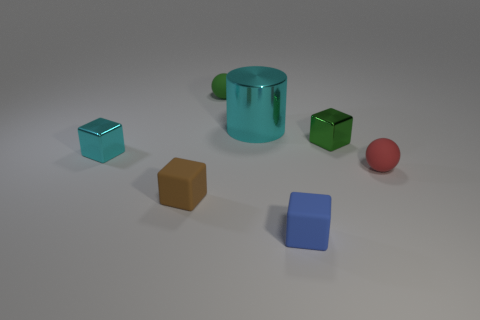Subtract all small blue matte blocks. How many blocks are left? 3 Subtract 2 cubes. How many cubes are left? 2 Subtract all brown blocks. How many blocks are left? 3 Add 2 tiny blue matte blocks. How many objects exist? 9 Subtract all cubes. How many objects are left? 3 Subtract all purple blocks. Subtract all yellow cylinders. How many blocks are left? 4 Subtract all brown blocks. Subtract all cyan metal things. How many objects are left? 4 Add 2 balls. How many balls are left? 4 Add 3 tiny red balls. How many tiny red balls exist? 4 Subtract 1 green spheres. How many objects are left? 6 